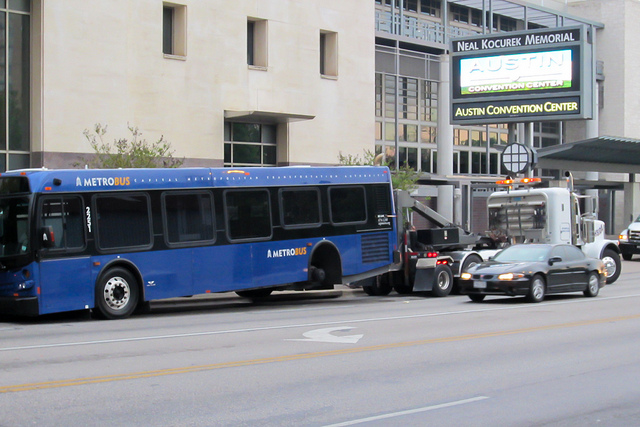<image>Is there writing on the windows? No, there is no writing on the windows. What form of entertainment is advertised? It is uncertain what form of entertainment is being advertised. It could be a concert, sports event, or a convention at the Austin Convention Center. Is there writing on the windows? No, there is no writing on the windows. What form of entertainment is advertised? I don't know what form of entertainment is advertised. It can be a concert, convention, sports event, or play. 